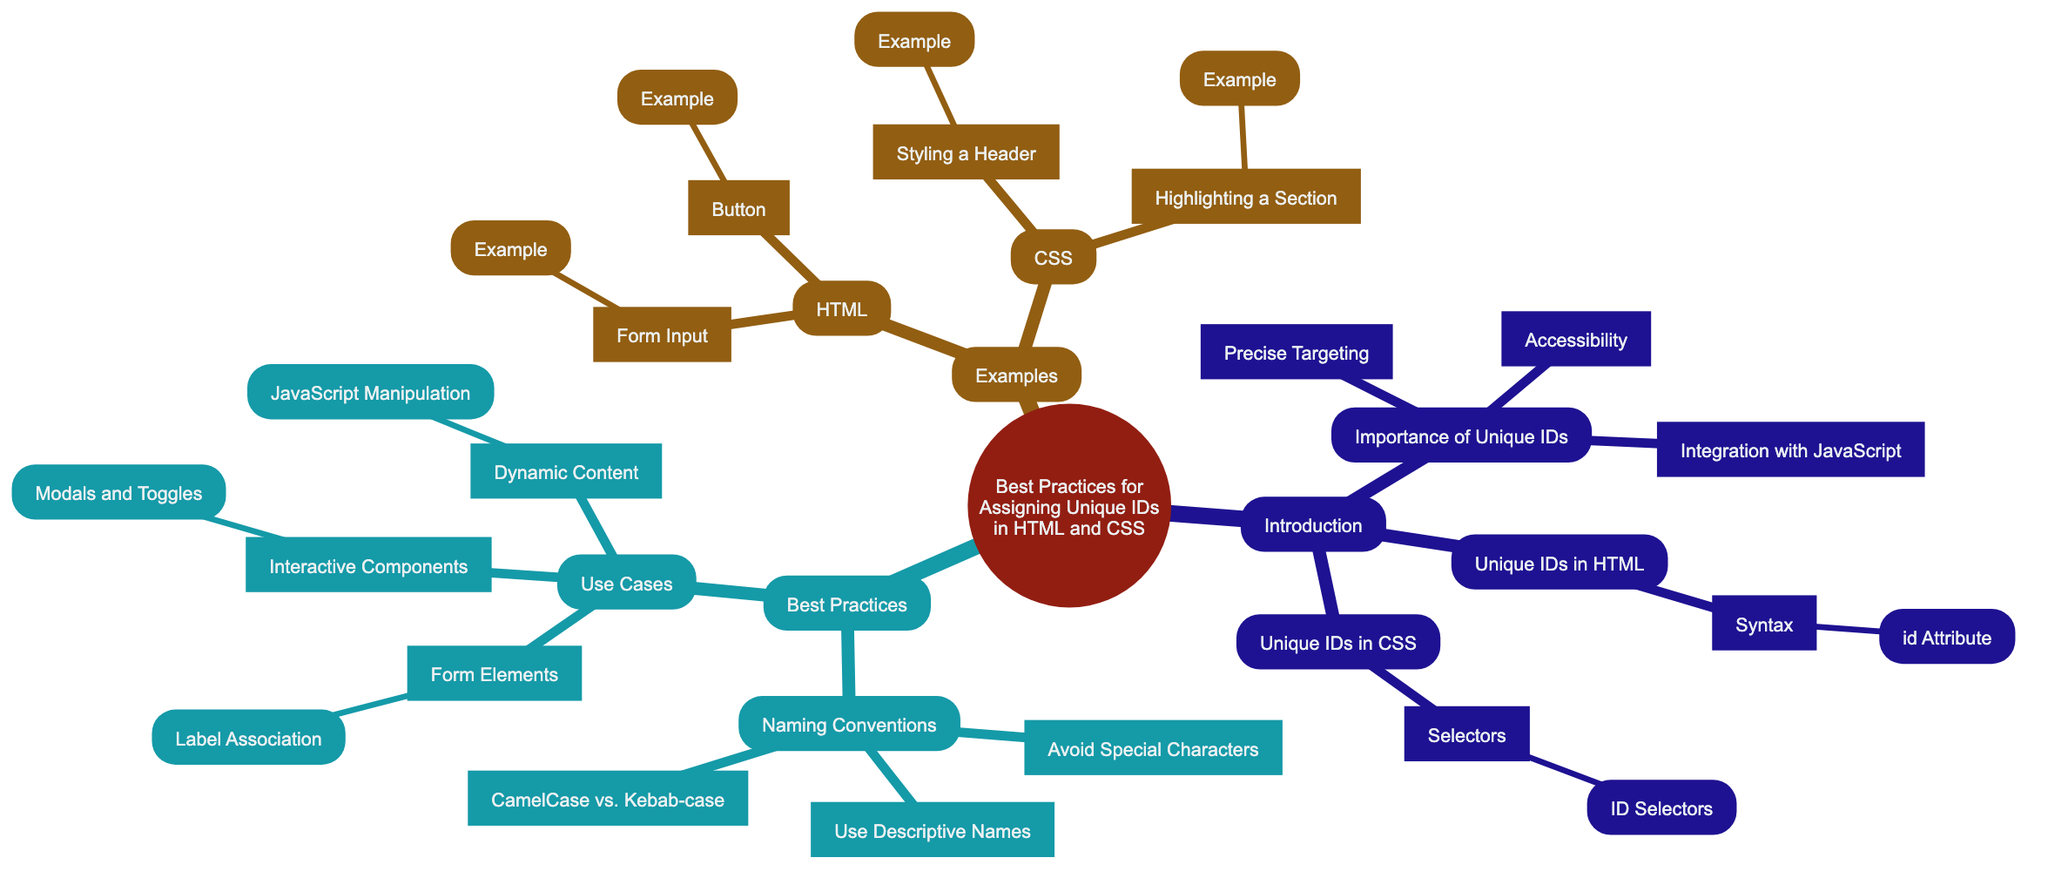What are the main sections in the Mind Map? The main sections in the Mind Map are "Introduction," "Best Practices," and "Examples." These represent the highest hierarchy in the diagram.
Answer: Introduction, Best Practices, Examples How many nodes are under "Importance of Unique IDs"? Under "Importance of Unique IDs," there are three nodes: "Precise Targeting," "Accessibility," and "Integration with JavaScript." This provides insight into the significance of unique IDs.
Answer: 3 What is the sub-node of "Unique IDs in HTML"? The sub-node of "Unique IDs in HTML" is "Syntax," which further elaborates on how unique IDs are structured in HTML.
Answer: Syntax Which best practice advises against special characters? The best practice advising against special characters is "Avoid Special Characters," which suggests users should keep ID names simple and clear.
Answer: Avoid Special Characters List one use case for unique IDs in the Mind Map. One use case for unique IDs is "Form Elements," highlighting their utility in associating forms and labels effectively.
Answer: Form Elements What is the relationship between "Naming Conventions" and "Use Cases"? "Naming Conventions" and "Use Cases" are both sub-sections under the "Best Practices" node, indicating that these practices are essential for the implementation of unique IDs.
Answer: They are both sub-sections of Best Practices Which section contains examples of HTML? The section that contains examples of HTML is the "Examples" section, specifically highlighting how unique IDs can be implemented within HTML code snippets.
Answer: Examples What is one example of CSS related to unique IDs? One example of CSS related to unique IDs is "Styling a Header," which demonstrates how IDs can be used to apply styles to specific elements.
Answer: Styling a Header What node is a child of "Use Cases"? A child node of "Use Cases" is "Form Elements," which addresses a specific area where unique IDs are essential for functionality.
Answer: Form Elements 